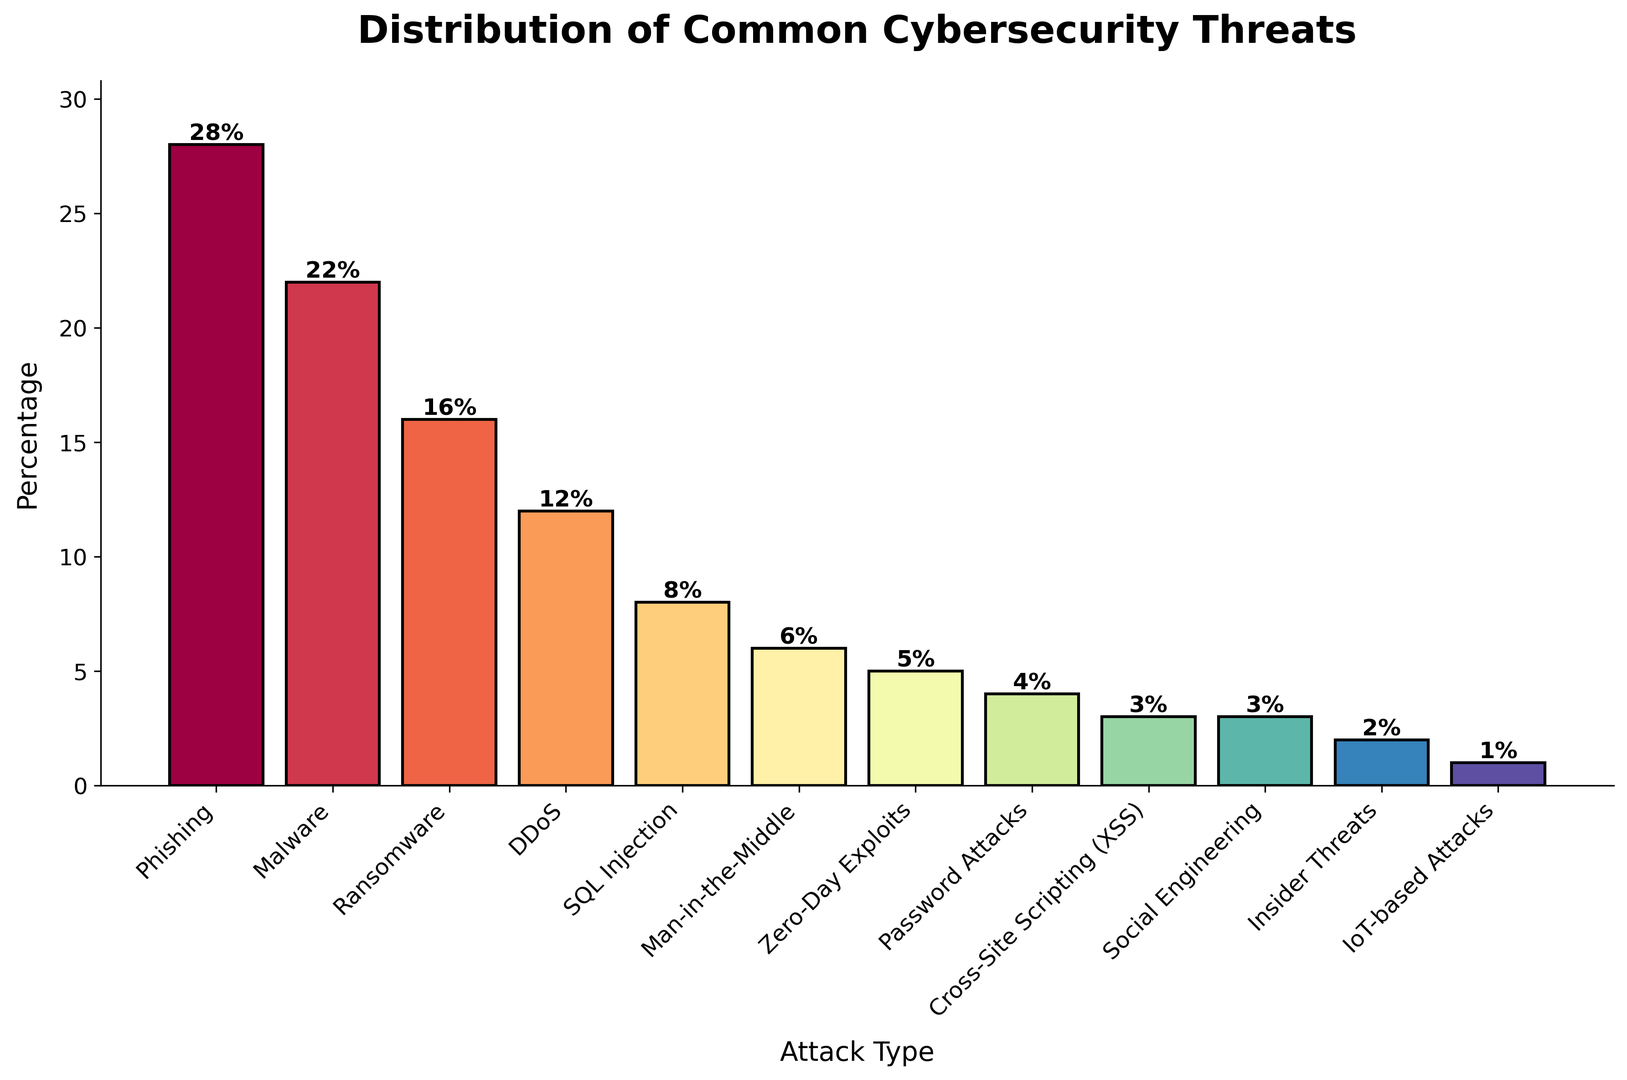Which attack type has the highest percentage? By examining the heights of the bars, the tallest bar represents the attack type with the highest percentage. The bar labeled "Phishing" is the tallest and reaches up to 28%.
Answer: Phishing Which attack type has the lowest percentage? By looking at the shortest bar in the chart, the bar labeled "IoT-based Attacks" is the shortest and reaches up to 1%.
Answer: IoT-based Attacks How many attack types have a percentage greater than 10%? Visual inspection of the chart shows that the bars labeled "Phishing", "Malware", "Ransomware", and "DDoS" exceed the 10% mark. This totals to 4 attack types.
Answer: 4 How does the percentage of Malware compare to DDoS? Find the bars labeled "Malware" and "DDoS". The Malware bar reaches 22%, while the DDoS bar reaches 12%. Therefore, Malware has a higher percentage than DDoS.
Answer: Malware has a higher percentage than DDoS What is the combined percentage of Ransomware and Password Attacks? Identify the percentages for Ransomware (16%) and Password Attacks (4%). Add these percentages together: 16% + 4% = 20%.
Answer: 20% Which attack types have a percentage that is equal? Look for bars that reach the same height. "Cross-Site Scripting (XSS)" and "Social Engineering" both reach 3%.
Answer: Cross-Site Scripting (XSS) and Social Engineering What is the average percentage of the top three most common attacks? Identify the top three percentages: Phishing (28%), Malware (22%), and Ransomware (16%). Calculate the average: (28 + 22 + 16) / 3 = 66 / 3 = 22%.
Answer: 22% What is the percentage difference between Phishing and SQL Injection? Find the percentages for Phishing (28%) and SQL Injection (8%). Subtract the lower percentage from the higher: 28% - 8% = 20%.
Answer: 20% Which attack type is represented with a color closest to the middle of the color spectrum used? The code divides colors using the Spectral map evenly across the attack types. The middle bar will be closest to this central color. Given 12 types, the 6th and 7th bars (Man-in-the-Middle and Zero-Day Exploits) will fall around the middle.
Answer: Man-in-the-Middle and Zero-Day Exploits 